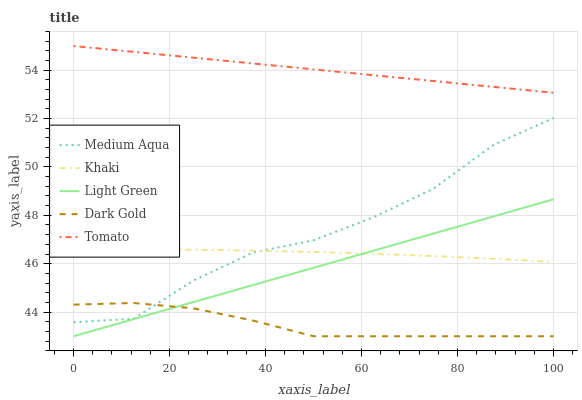Does Dark Gold have the minimum area under the curve?
Answer yes or no. Yes. Does Tomato have the maximum area under the curve?
Answer yes or no. Yes. Does Khaki have the minimum area under the curve?
Answer yes or no. No. Does Khaki have the maximum area under the curve?
Answer yes or no. No. Is Tomato the smoothest?
Answer yes or no. Yes. Is Medium Aqua the roughest?
Answer yes or no. Yes. Is Khaki the smoothest?
Answer yes or no. No. Is Khaki the roughest?
Answer yes or no. No. Does Light Green have the lowest value?
Answer yes or no. Yes. Does Khaki have the lowest value?
Answer yes or no. No. Does Tomato have the highest value?
Answer yes or no. Yes. Does Khaki have the highest value?
Answer yes or no. No. Is Light Green less than Medium Aqua?
Answer yes or no. Yes. Is Khaki greater than Dark Gold?
Answer yes or no. Yes. Does Medium Aqua intersect Dark Gold?
Answer yes or no. Yes. Is Medium Aqua less than Dark Gold?
Answer yes or no. No. Is Medium Aqua greater than Dark Gold?
Answer yes or no. No. Does Light Green intersect Medium Aqua?
Answer yes or no. No. 